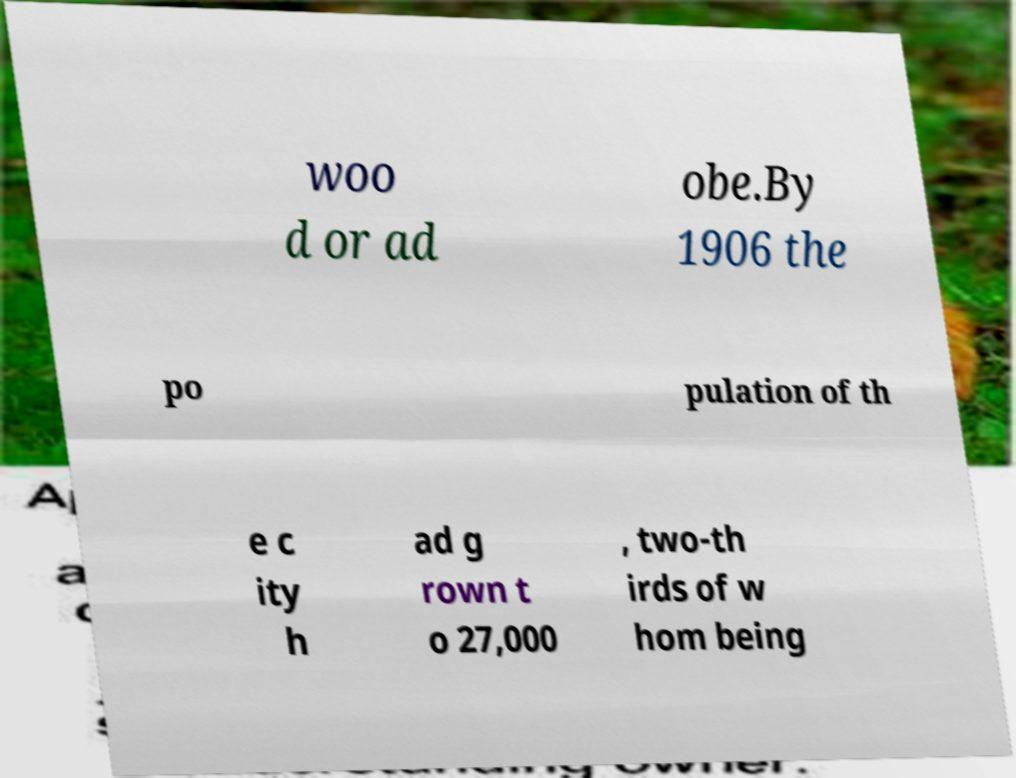There's text embedded in this image that I need extracted. Can you transcribe it verbatim? woo d or ad obe.By 1906 the po pulation of th e c ity h ad g rown t o 27,000 , two-th irds of w hom being 